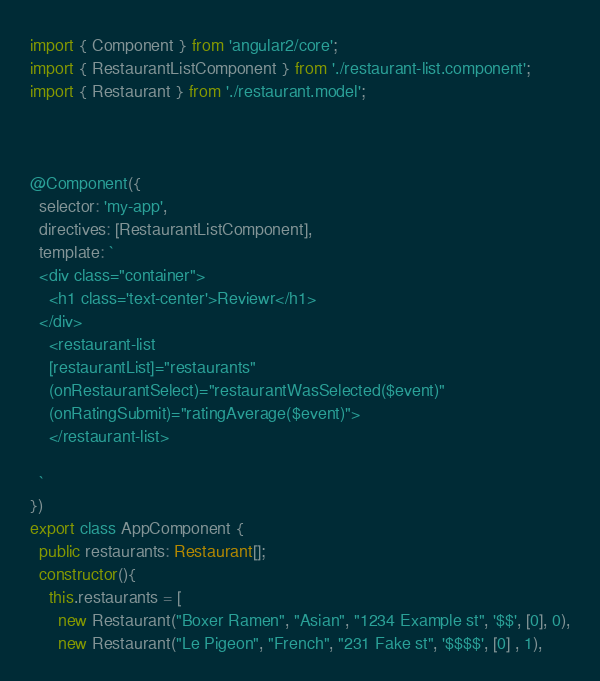<code> <loc_0><loc_0><loc_500><loc_500><_TypeScript_>import { Component } from 'angular2/core';
import { RestaurantListComponent } from './restaurant-list.component';
import { Restaurant } from './restaurant.model';



@Component({
  selector: 'my-app',
  directives: [RestaurantListComponent],
  template: `
  <div class="container">
  	<h1 class='text-center'>Reviewr</h1>
  </div>
    <restaurant-list
    [restaurantList]="restaurants"
    (onRestaurantSelect)="restaurantWasSelected($event)"
    (onRatingSubmit)="ratingAverage($event)">
    </restaurant-list>

  `
})
export class AppComponent {
  public restaurants: Restaurant[];
  constructor(){
    this.restaurants = [
      new Restaurant("Boxer Ramen", "Asian", "1234 Example st", '$$', [0], 0),
      new Restaurant("Le Pigeon", "French", "231 Fake st", '$$$$', [0] , 1),</code> 